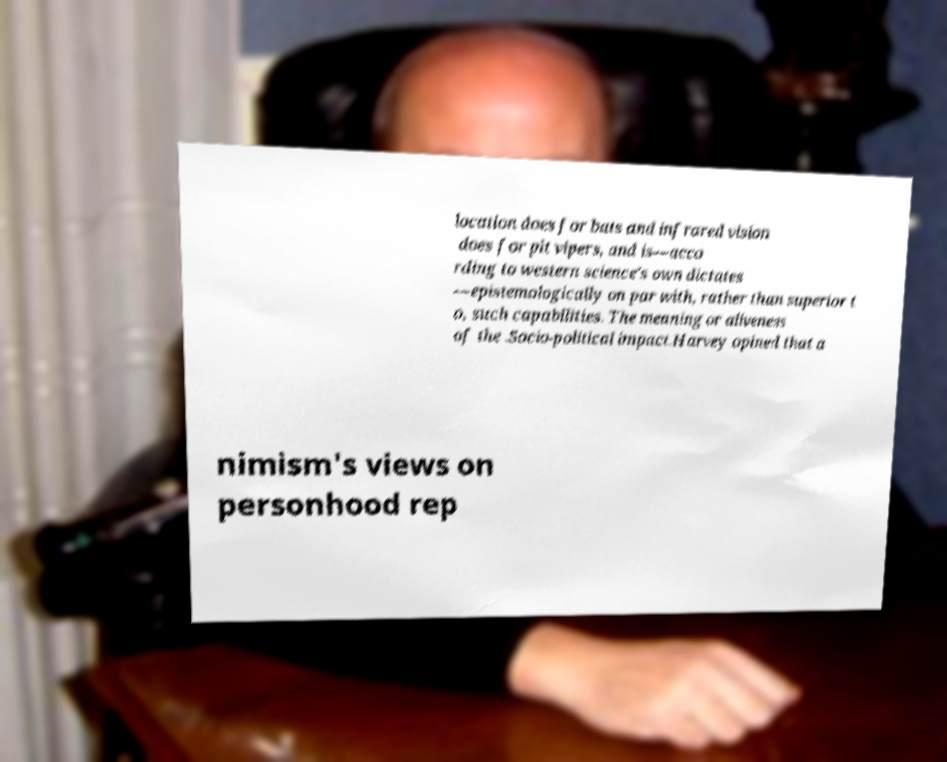I need the written content from this picture converted into text. Can you do that? location does for bats and infrared vision does for pit vipers, and is—acco rding to western science's own dictates —epistemologically on par with, rather than superior t o, such capabilities. The meaning or aliveness of the .Socio-political impact.Harvey opined that a nimism's views on personhood rep 